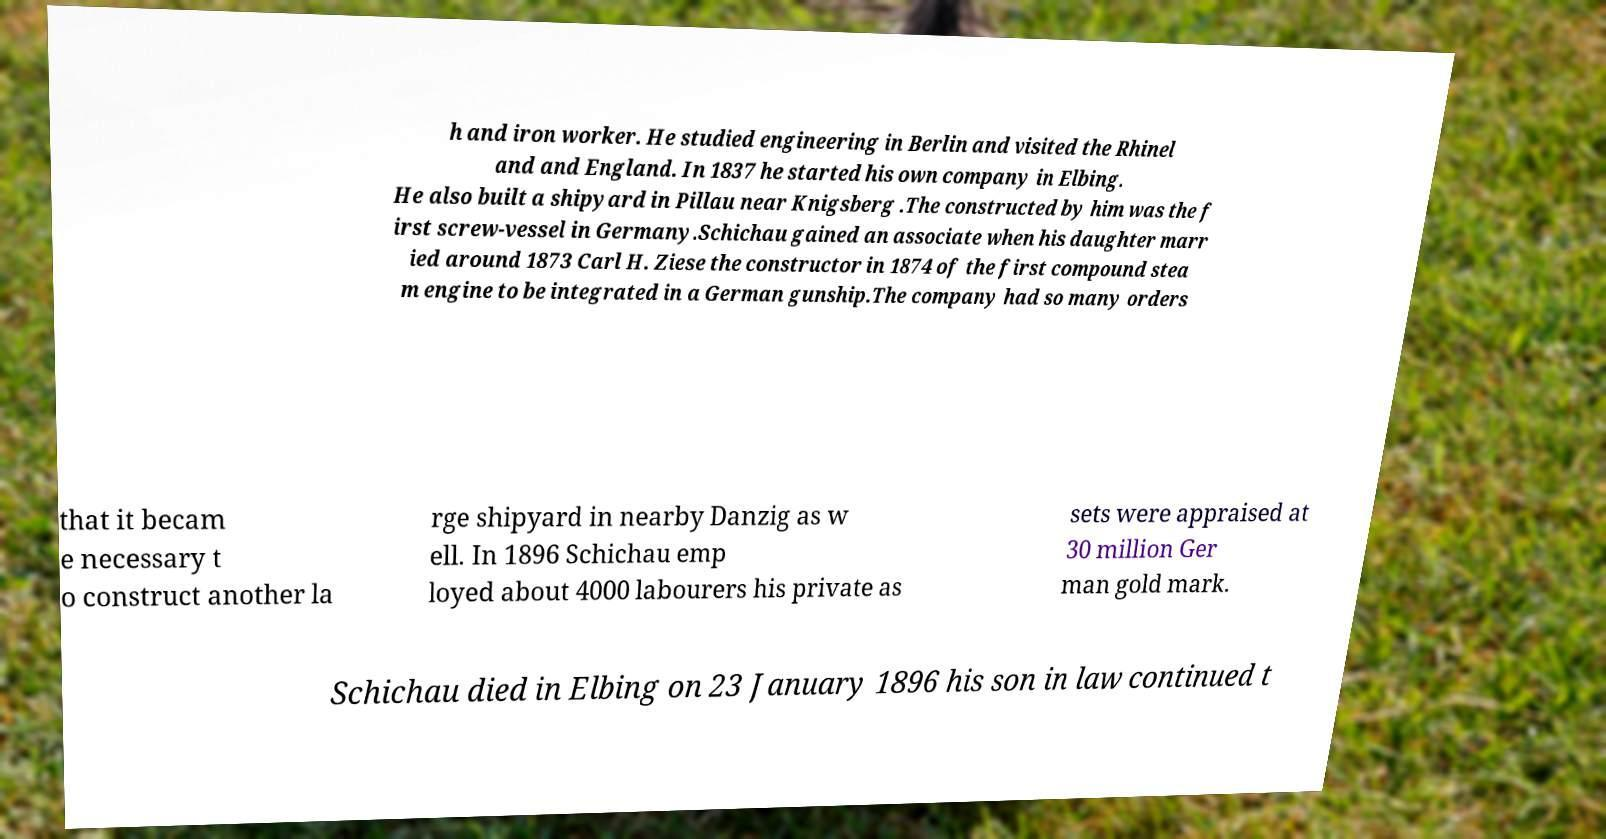I need the written content from this picture converted into text. Can you do that? h and iron worker. He studied engineering in Berlin and visited the Rhinel and and England. In 1837 he started his own company in Elbing. He also built a shipyard in Pillau near Knigsberg .The constructed by him was the f irst screw-vessel in Germany.Schichau gained an associate when his daughter marr ied around 1873 Carl H. Ziese the constructor in 1874 of the first compound stea m engine to be integrated in a German gunship.The company had so many orders that it becam e necessary t o construct another la rge shipyard in nearby Danzig as w ell. In 1896 Schichau emp loyed about 4000 labourers his private as sets were appraised at 30 million Ger man gold mark. Schichau died in Elbing on 23 January 1896 his son in law continued t 